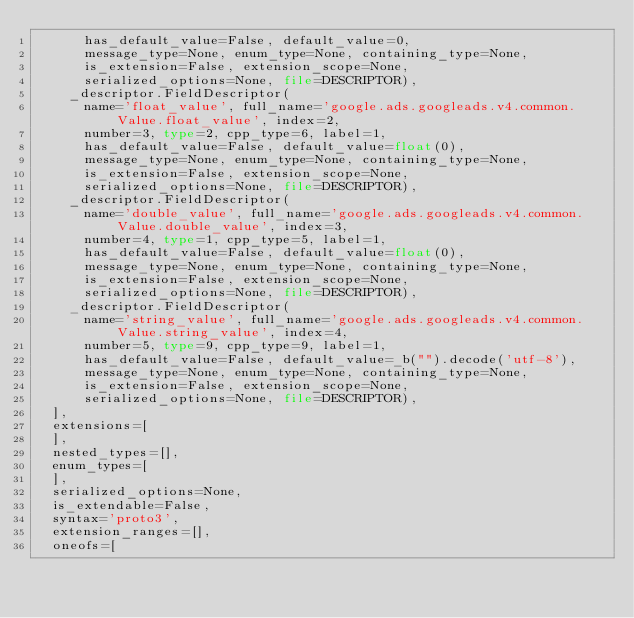Convert code to text. <code><loc_0><loc_0><loc_500><loc_500><_Python_>      has_default_value=False, default_value=0,
      message_type=None, enum_type=None, containing_type=None,
      is_extension=False, extension_scope=None,
      serialized_options=None, file=DESCRIPTOR),
    _descriptor.FieldDescriptor(
      name='float_value', full_name='google.ads.googleads.v4.common.Value.float_value', index=2,
      number=3, type=2, cpp_type=6, label=1,
      has_default_value=False, default_value=float(0),
      message_type=None, enum_type=None, containing_type=None,
      is_extension=False, extension_scope=None,
      serialized_options=None, file=DESCRIPTOR),
    _descriptor.FieldDescriptor(
      name='double_value', full_name='google.ads.googleads.v4.common.Value.double_value', index=3,
      number=4, type=1, cpp_type=5, label=1,
      has_default_value=False, default_value=float(0),
      message_type=None, enum_type=None, containing_type=None,
      is_extension=False, extension_scope=None,
      serialized_options=None, file=DESCRIPTOR),
    _descriptor.FieldDescriptor(
      name='string_value', full_name='google.ads.googleads.v4.common.Value.string_value', index=4,
      number=5, type=9, cpp_type=9, label=1,
      has_default_value=False, default_value=_b("").decode('utf-8'),
      message_type=None, enum_type=None, containing_type=None,
      is_extension=False, extension_scope=None,
      serialized_options=None, file=DESCRIPTOR),
  ],
  extensions=[
  ],
  nested_types=[],
  enum_types=[
  ],
  serialized_options=None,
  is_extendable=False,
  syntax='proto3',
  extension_ranges=[],
  oneofs=[</code> 